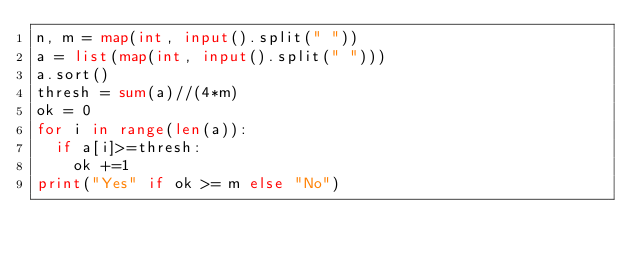Convert code to text. <code><loc_0><loc_0><loc_500><loc_500><_Python_>n, m = map(int, input().split(" "))
a = list(map(int, input().split(" ")))
a.sort()
thresh = sum(a)//(4*m)
ok = 0
for i in range(len(a)):
  if a[i]>=thresh:
    ok +=1
print("Yes" if ok >= m else "No")</code> 